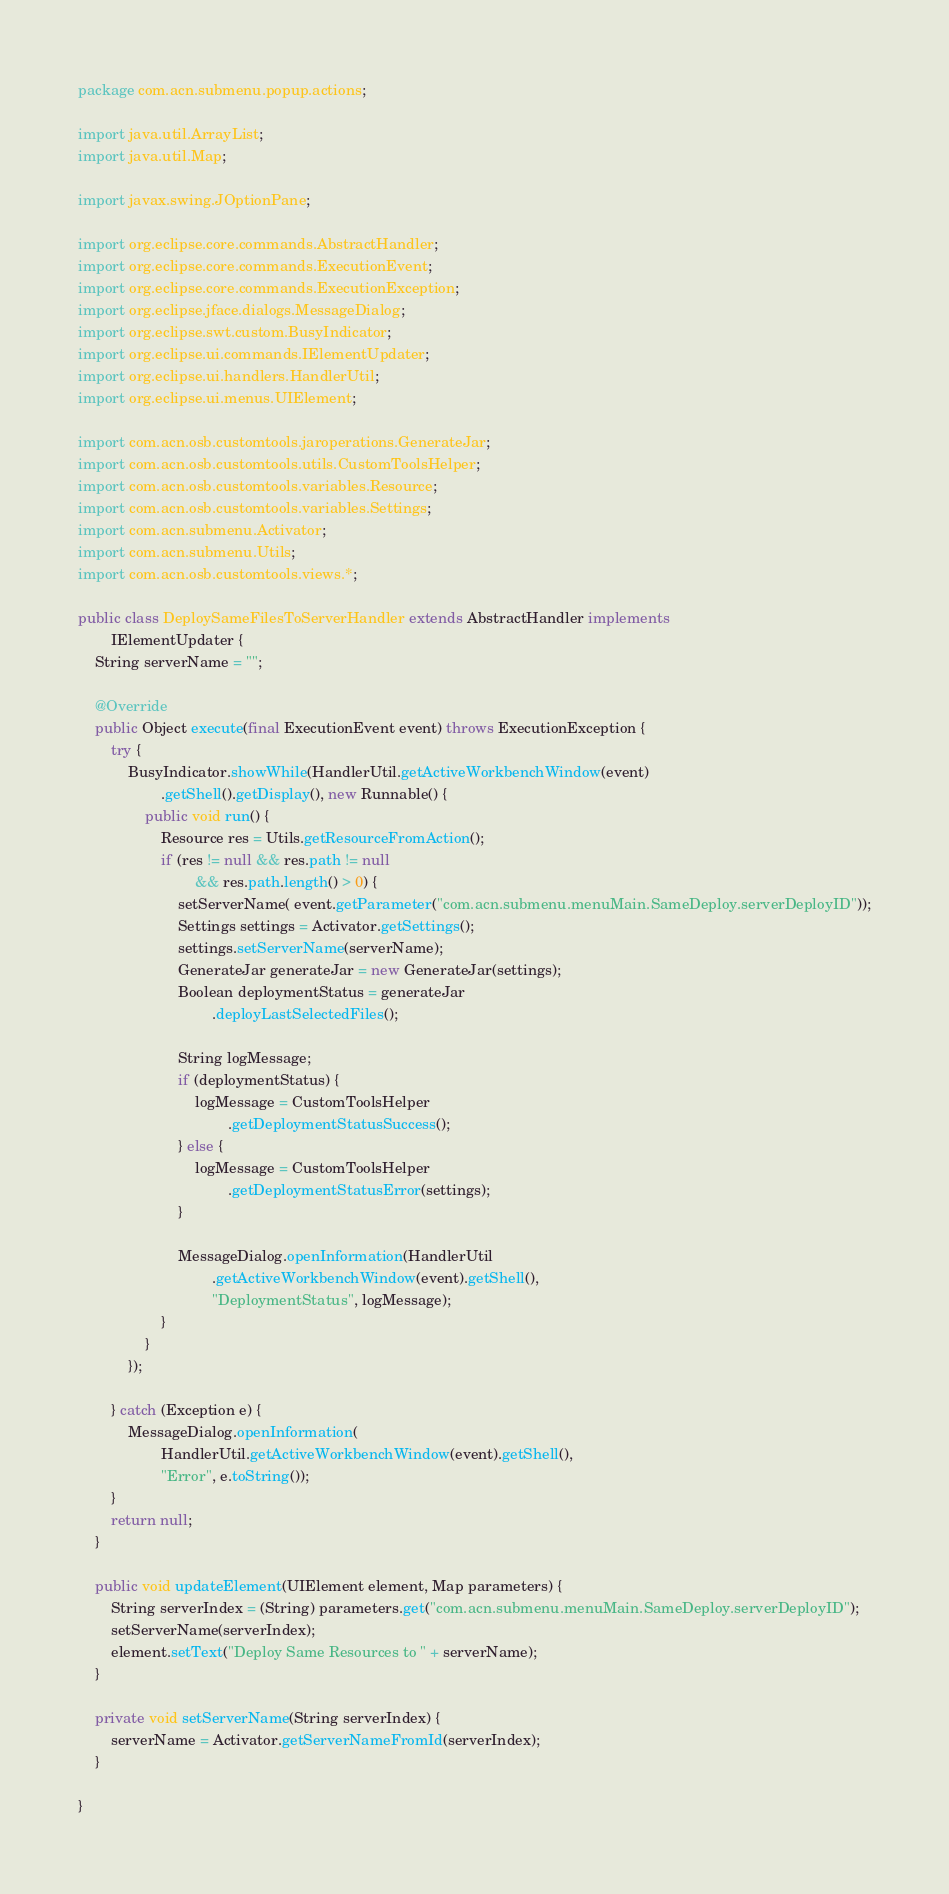Convert code to text. <code><loc_0><loc_0><loc_500><loc_500><_Java_>package com.acn.submenu.popup.actions;

import java.util.ArrayList;
import java.util.Map;

import javax.swing.JOptionPane;

import org.eclipse.core.commands.AbstractHandler;
import org.eclipse.core.commands.ExecutionEvent;
import org.eclipse.core.commands.ExecutionException;
import org.eclipse.jface.dialogs.MessageDialog;
import org.eclipse.swt.custom.BusyIndicator;
import org.eclipse.ui.commands.IElementUpdater;
import org.eclipse.ui.handlers.HandlerUtil;
import org.eclipse.ui.menus.UIElement;

import com.acn.osb.customtools.jaroperations.GenerateJar;
import com.acn.osb.customtools.utils.CustomToolsHelper;
import com.acn.osb.customtools.variables.Resource;
import com.acn.osb.customtools.variables.Settings;
import com.acn.submenu.Activator;
import com.acn.submenu.Utils;
import com.acn.osb.customtools.views.*;

public class DeploySameFilesToServerHandler extends AbstractHandler implements
		IElementUpdater {
	String serverName = "";

	@Override
	public Object execute(final ExecutionEvent event) throws ExecutionException {
		try {
			BusyIndicator.showWhile(HandlerUtil.getActiveWorkbenchWindow(event)
					.getShell().getDisplay(), new Runnable() {
				public void run() {
					Resource res = Utils.getResourceFromAction();
					if (res != null && res.path != null
							&& res.path.length() > 0) {
						setServerName( event.getParameter("com.acn.submenu.menuMain.SameDeploy.serverDeployID"));
						Settings settings = Activator.getSettings();
						settings.setServerName(serverName);
						GenerateJar generateJar = new GenerateJar(settings);
						Boolean deploymentStatus = generateJar
								.deployLastSelectedFiles();

						String logMessage;
						if (deploymentStatus) {
							logMessage = CustomToolsHelper
									.getDeploymentStatusSuccess();
						} else {
							logMessage = CustomToolsHelper
									.getDeploymentStatusError(settings);
						}

						MessageDialog.openInformation(HandlerUtil
								.getActiveWorkbenchWindow(event).getShell(),
								"DeploymentStatus", logMessage);
					}
				}
			});

		} catch (Exception e) {
			MessageDialog.openInformation(
					HandlerUtil.getActiveWorkbenchWindow(event).getShell(),
					"Error", e.toString());
		}
		return null;
	}

	public void updateElement(UIElement element, Map parameters) {
		String serverIndex = (String) parameters.get("com.acn.submenu.menuMain.SameDeploy.serverDeployID");
		setServerName(serverIndex);
		element.setText("Deploy Same Resources to " + serverName);
	}

	private void setServerName(String serverIndex) {
		serverName = Activator.getServerNameFromId(serverIndex);
	}

}
</code> 